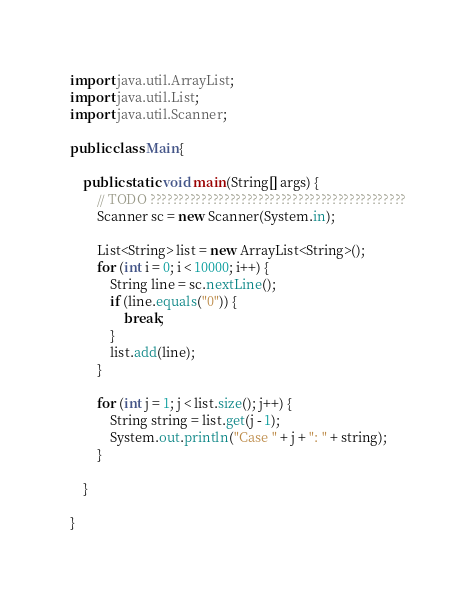Convert code to text. <code><loc_0><loc_0><loc_500><loc_500><_Java_>import java.util.ArrayList;
import java.util.List;
import java.util.Scanner;

public class Main{

	public static void main(String[] args) {
		// TODO ?????????????????????????????????????????????
		Scanner sc = new Scanner(System.in);

		List<String> list = new ArrayList<String>();
		for (int i = 0; i < 10000; i++) {
			String line = sc.nextLine();
			if (line.equals("0")) {
				break;
			}
			list.add(line);
		}

		for (int j = 1; j < list.size(); j++) {
			String string = list.get(j - 1);
			System.out.println("Case " + j + ": " + string);
		}

	}

}</code> 